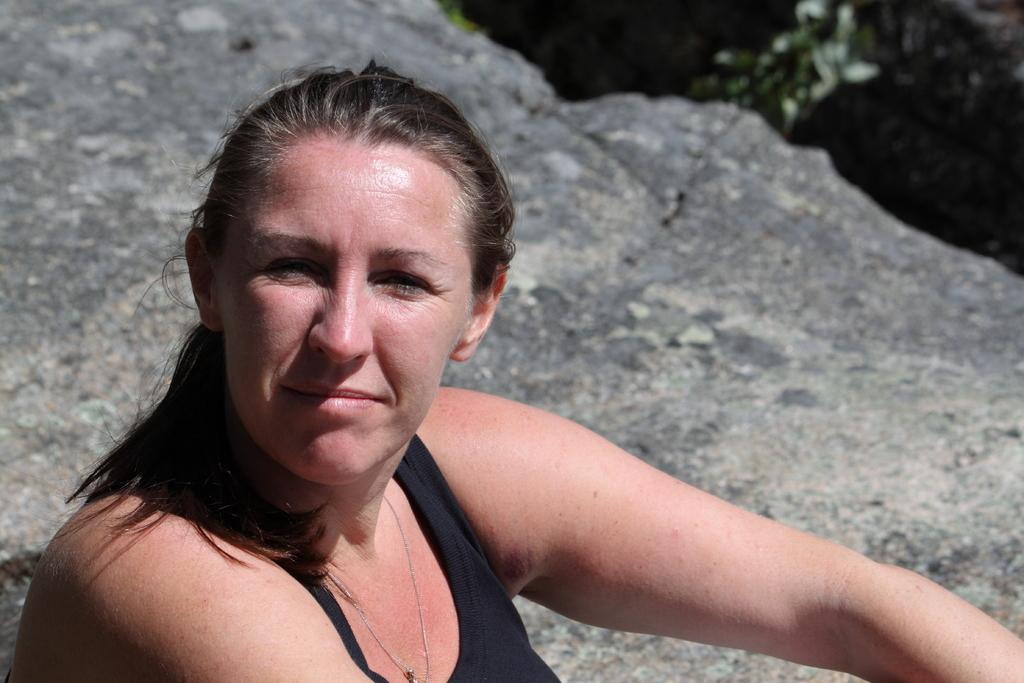What type of setting is depicted in the image? The image has an outside view. Can you describe the person in the image? There is a person in the image, and they are at the bottom of the image. What is the person wearing? The person is wearing clothes. What can be seen behind the person? There is a rock behind the person. Is there a vase in the image where the person is having a meeting? There is no vase or meeting present in the image; it shows a person standing in an outside setting with a rock behind them. 